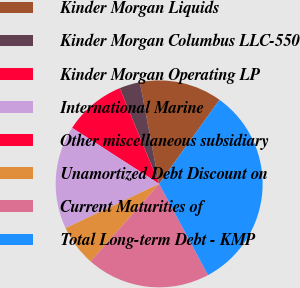Convert chart. <chart><loc_0><loc_0><loc_500><loc_500><pie_chart><fcel>Kinder Morgan Liquids<fcel>Kinder Morgan Columbus LLC-550<fcel>Kinder Morgan Operating LP<fcel>International Marine<fcel>Other miscellaneous subsidiary<fcel>Unamortized Debt Discount on<fcel>Current Maturities of<fcel>Total Long-term Debt - KMP<nl><fcel>12.9%<fcel>3.23%<fcel>9.68%<fcel>16.13%<fcel>0.0%<fcel>6.45%<fcel>19.35%<fcel>32.25%<nl></chart> 